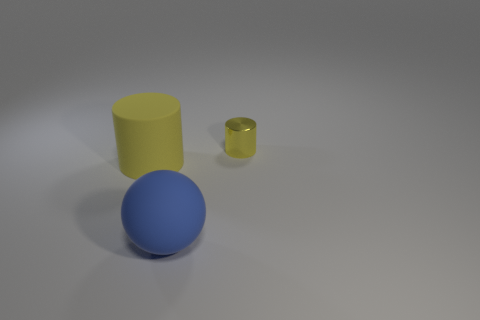Add 1 small cylinders. How many objects exist? 4 Add 3 tiny shiny spheres. How many tiny shiny spheres exist? 3 Subtract 0 red cubes. How many objects are left? 3 Subtract all balls. How many objects are left? 2 Subtract 1 spheres. How many spheres are left? 0 Subtract all gray spheres. Subtract all red cubes. How many spheres are left? 1 Subtract all cyan balls. How many purple cylinders are left? 0 Subtract all yellow cylinders. Subtract all rubber cylinders. How many objects are left? 0 Add 3 tiny metallic things. How many tiny metallic things are left? 4 